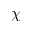Convert formula to latex. <formula><loc_0><loc_0><loc_500><loc_500>\chi</formula> 